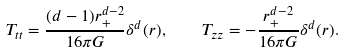<formula> <loc_0><loc_0><loc_500><loc_500>T _ { t t } = \frac { ( d - 1 ) r _ { + } ^ { d - 2 } } { 1 6 \pi G } \delta ^ { d } ( r ) , \quad T _ { z z } = - \frac { r _ { + } ^ { d - 2 } } { 1 6 \pi G } \delta ^ { d } ( r ) .</formula> 